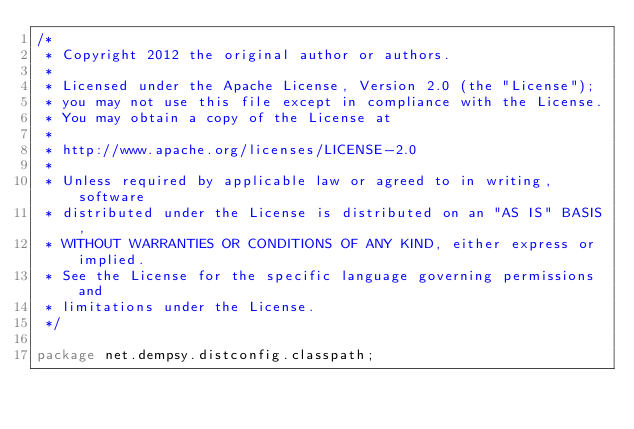<code> <loc_0><loc_0><loc_500><loc_500><_Java_>/*
 * Copyright 2012 the original author or authors.
 *
 * Licensed under the Apache License, Version 2.0 (the "License");
 * you may not use this file except in compliance with the License.
 * You may obtain a copy of the License at
 *
 * http://www.apache.org/licenses/LICENSE-2.0
 *
 * Unless required by applicable law or agreed to in writing, software
 * distributed under the License is distributed on an "AS IS" BASIS,
 * WITHOUT WARRANTIES OR CONDITIONS OF ANY KIND, either express or implied.
 * See the License for the specific language governing permissions and
 * limitations under the License.
 */

package net.dempsy.distconfig.classpath;
</code> 